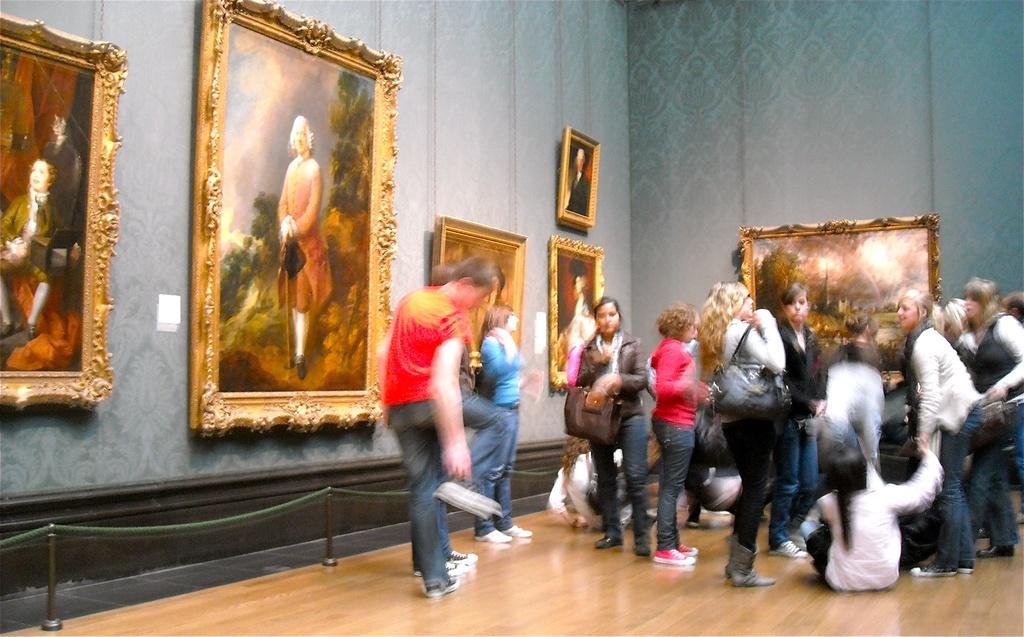Can you describe this image briefly? As we can see in the image there is a wall, photo frames and few people here and there. 